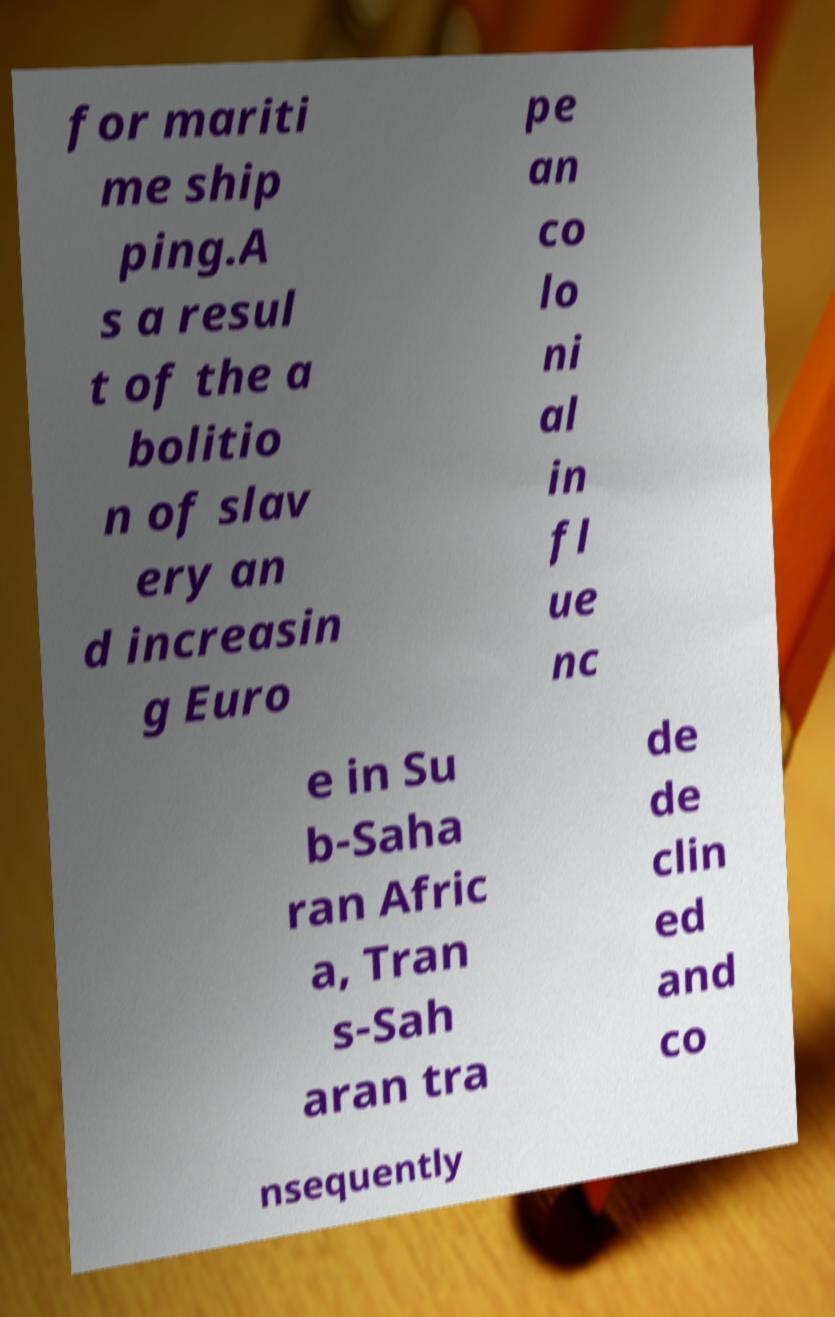Can you accurately transcribe the text from the provided image for me? for mariti me ship ping.A s a resul t of the a bolitio n of slav ery an d increasin g Euro pe an co lo ni al in fl ue nc e in Su b-Saha ran Afric a, Tran s-Sah aran tra de de clin ed and co nsequently 